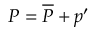<formula> <loc_0><loc_0><loc_500><loc_500>P = \overline { P } + p ^ { \prime }</formula> 